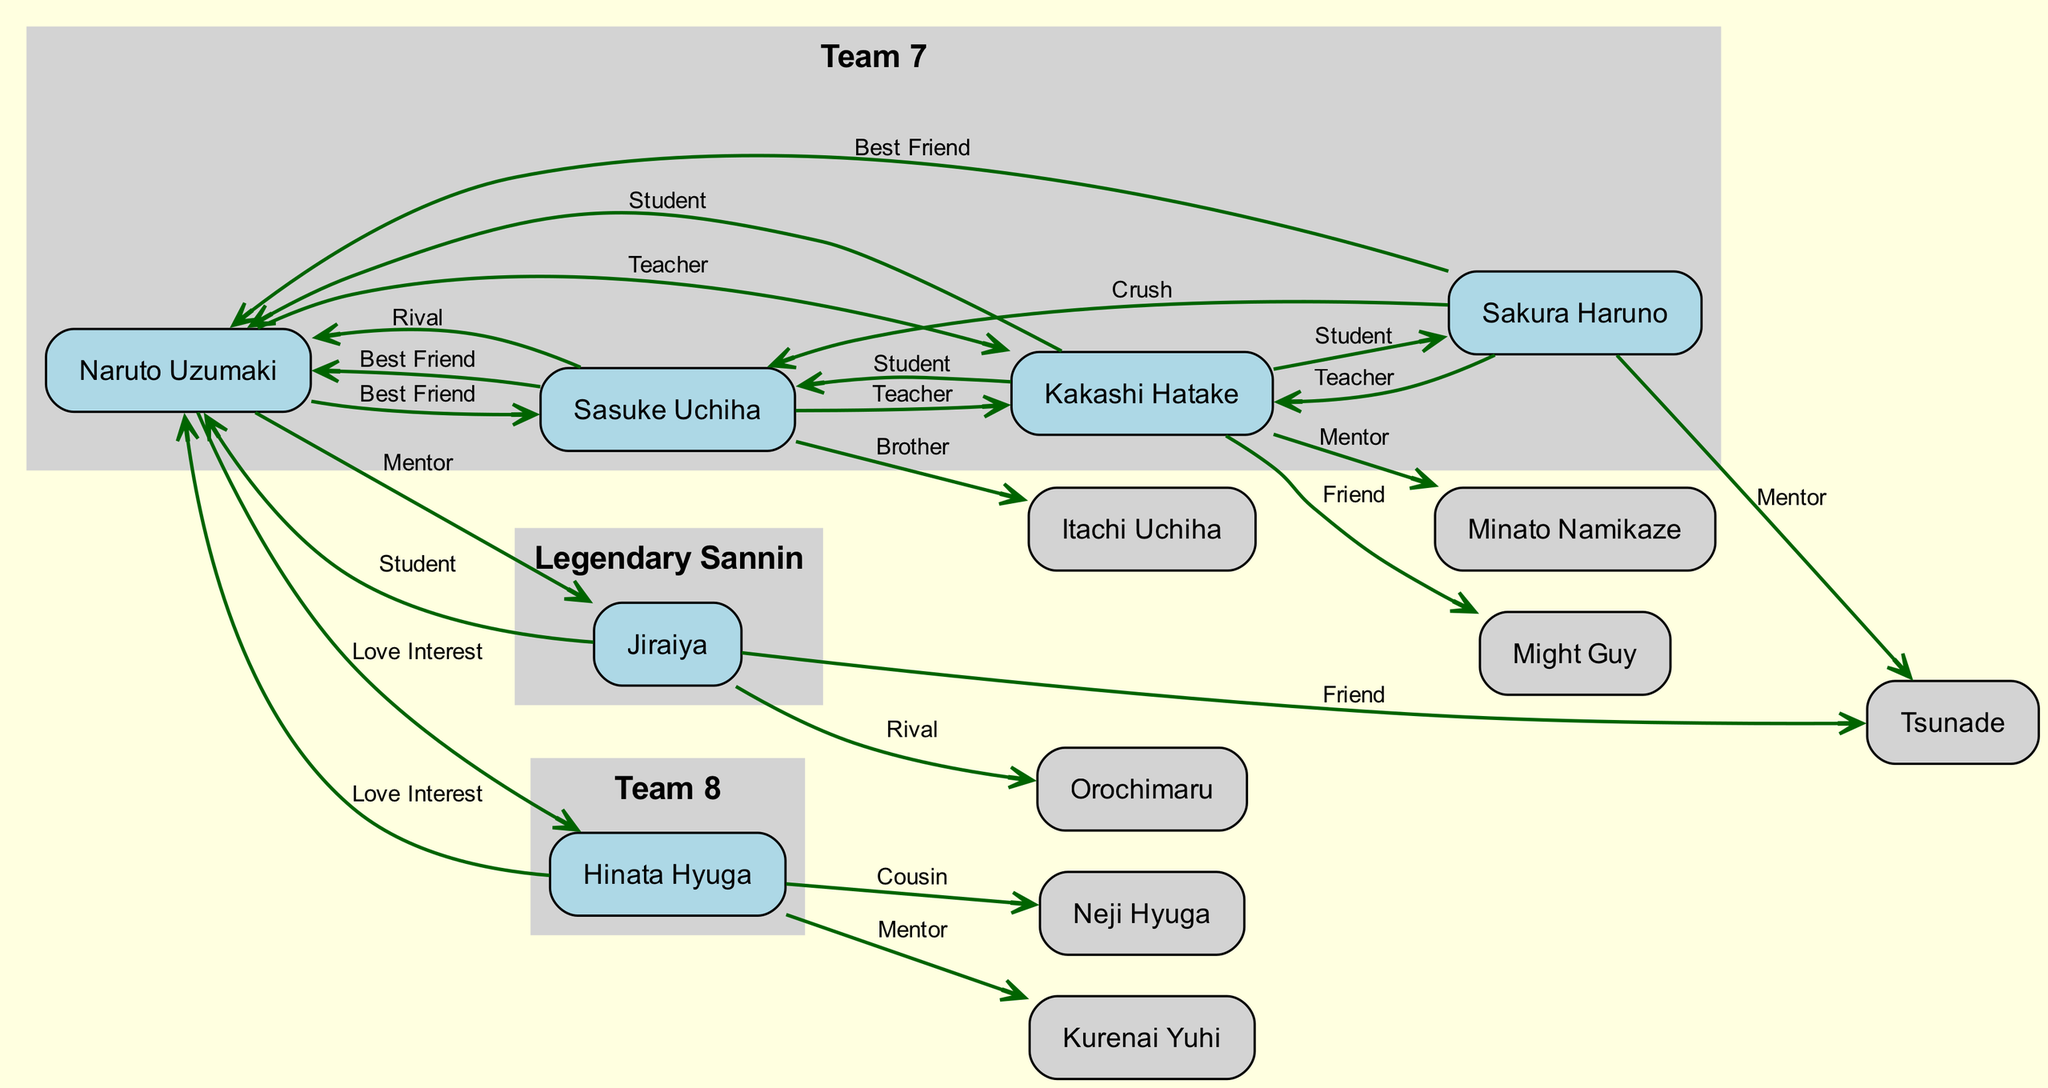What is Naruto's Love Interest? The diagram indicates that Naruto Uzumaki's Love Interest is Hinata Hyuga. This relationship is directly linked from Naruto to Hinata, as labeled in the edges.
Answer: Hinata Hyuga Who is Sasuke's Brother? According to the diagram, Sasuke Uchiha's Brother is Itachi Uchiha. The relationship is indicated with a direct edge connecting Sasuke to Itachi labeled as "Brother."
Answer: Itachi Uchiha How many main characters are there in the diagram? By counting the nodes representing characters, we find there are six main characters: Naruto, Sasuke, Sakura, Kakashi, Hinata, and Jiraiya.
Answer: 6 Which group is Kakashi affiliated with? The diagram shows that Kakashi Hatake is affiliated with both Team 7 and Anbu Black Ops. The group affiliations are listed next to his node and separate from the relationships.
Answer: Team 7, Anbu Black Ops Who are the students of Kakashi Hatake? The diagram reveals that Kakashi Hatake's students are Naruto Uzumaki, Sasuke Uchiha, and Sakura Haruno. The edges labeled "Student" lead to these characters.
Answer: Naruto Uzumaki, Sasuke Uchiha, Sakura Haruno What type of relationship exists between Naruto and Sasuke? The diagram specifies that Naruto Uzumaki and Sasuke Uchiha have a "Best Friend" relationship as well as a "Rival" relationship. There are edges showing both of these connections.
Answer: Best Friend, Rival Which character is the Mentor of Sakura Haruno? The diagram indicates that Sakura Haruno's Mentor is Tsunade. This relationship is depicted as an edge directed from Sakura to Tsunade labeled "Mentor."
Answer: Tsunade How many relationships does Hinata Hyuga have in the diagram? By examining Hinata Hyuga's connections, we see that she has three relationships: Love Interest (Naruto), Cousin (Neji), and Mentor (Kurenai). This totals to three distinct relationships.
Answer: 3 Which character has a rivalry with Orochimaru? The diagram shows that Jiraiya has a rivalry represented by the edge labeled "Rival" connecting him to Orochimaru. This specifies their competitive relationship.
Answer: Orochimaru 